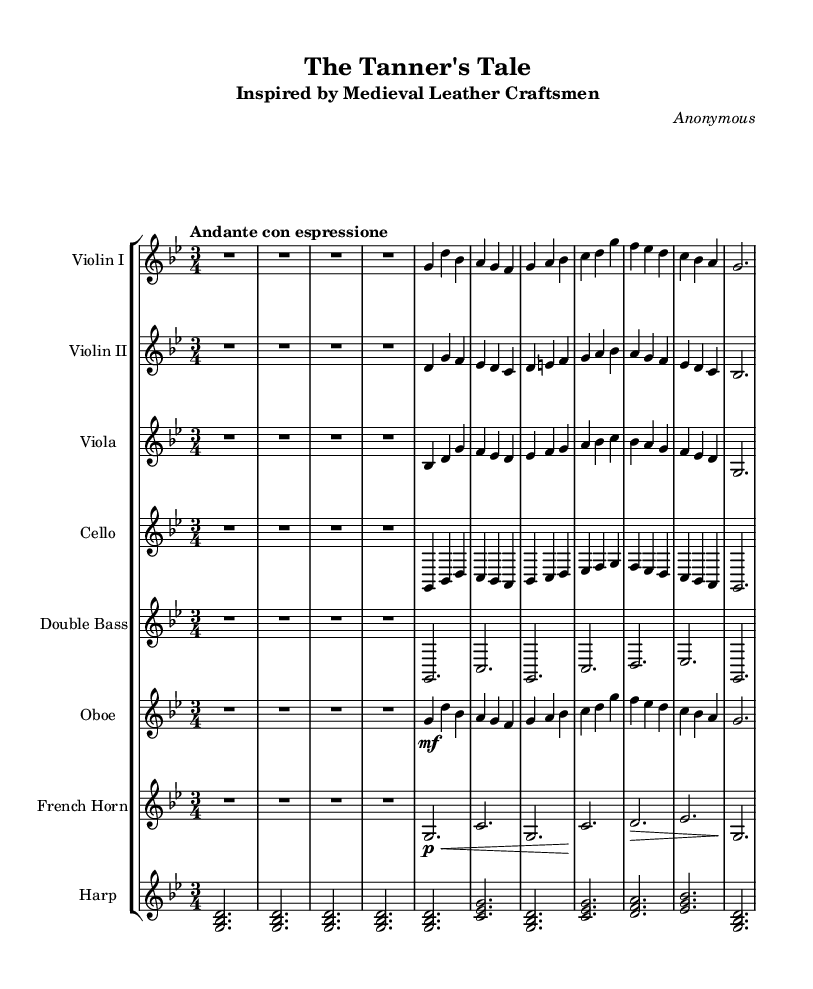What is the key signature of this music? The key signature indicated is G minor, as seen by the two flats (B♭ and E♭) in the staff.
Answer: G minor What is the time signature of the piece? The time signature is 3/4, which can be identified as there are three beats per measure and each beat is a quarter note.
Answer: 3/4 What is the tempo marking for the piece? The tempo marking is "Andante con espressione," indicating a moderately slow tempo with expressiveness.
Answer: Andante con espressione How many measures are there in total? To find the total number of measures, we can count the measures from the beginning to the end. There are 16 measures in total displayed in the music.
Answer: 16 Which instruments are included in the orchestration? The orchestration includes Violin I, Violin II, Viola, Cello, Double Bass, Oboe, French Horn, and Harp.
Answer: Violin I, Violin II, Viola, Cello, Double Bass, Oboe, French Horn, Harp Which instrument plays the initial melody? The initial melody is played by Violin I, as it is the higher-pitched line presented first in the score.
Answer: Violin I How does the harmony in the piece reflect Romantic characteristics? The harmony is rich and emotive, using chromaticism and lush chords typical of the Romantic style, which aims to evoke strong feelings reminiscent of the craftsmanship in leatherwork.
Answer: Rich and emotive harmony 